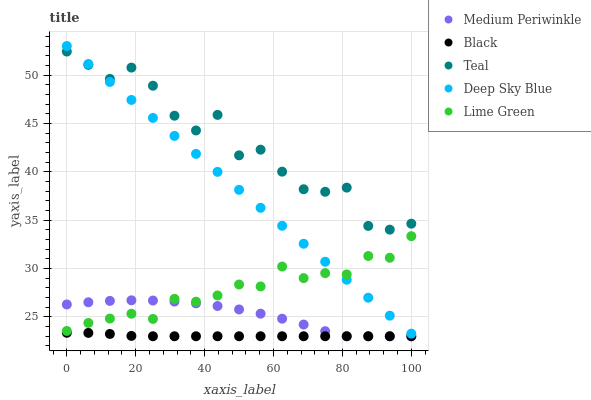Does Black have the minimum area under the curve?
Answer yes or no. Yes. Does Teal have the maximum area under the curve?
Answer yes or no. Yes. Does Medium Periwinkle have the minimum area under the curve?
Answer yes or no. No. Does Medium Periwinkle have the maximum area under the curve?
Answer yes or no. No. Is Deep Sky Blue the smoothest?
Answer yes or no. Yes. Is Teal the roughest?
Answer yes or no. Yes. Is Black the smoothest?
Answer yes or no. No. Is Black the roughest?
Answer yes or no. No. Does Black have the lowest value?
Answer yes or no. Yes. Does Deep Sky Blue have the lowest value?
Answer yes or no. No. Does Deep Sky Blue have the highest value?
Answer yes or no. Yes. Does Medium Periwinkle have the highest value?
Answer yes or no. No. Is Black less than Teal?
Answer yes or no. Yes. Is Teal greater than Lime Green?
Answer yes or no. Yes. Does Deep Sky Blue intersect Lime Green?
Answer yes or no. Yes. Is Deep Sky Blue less than Lime Green?
Answer yes or no. No. Is Deep Sky Blue greater than Lime Green?
Answer yes or no. No. Does Black intersect Teal?
Answer yes or no. No. 